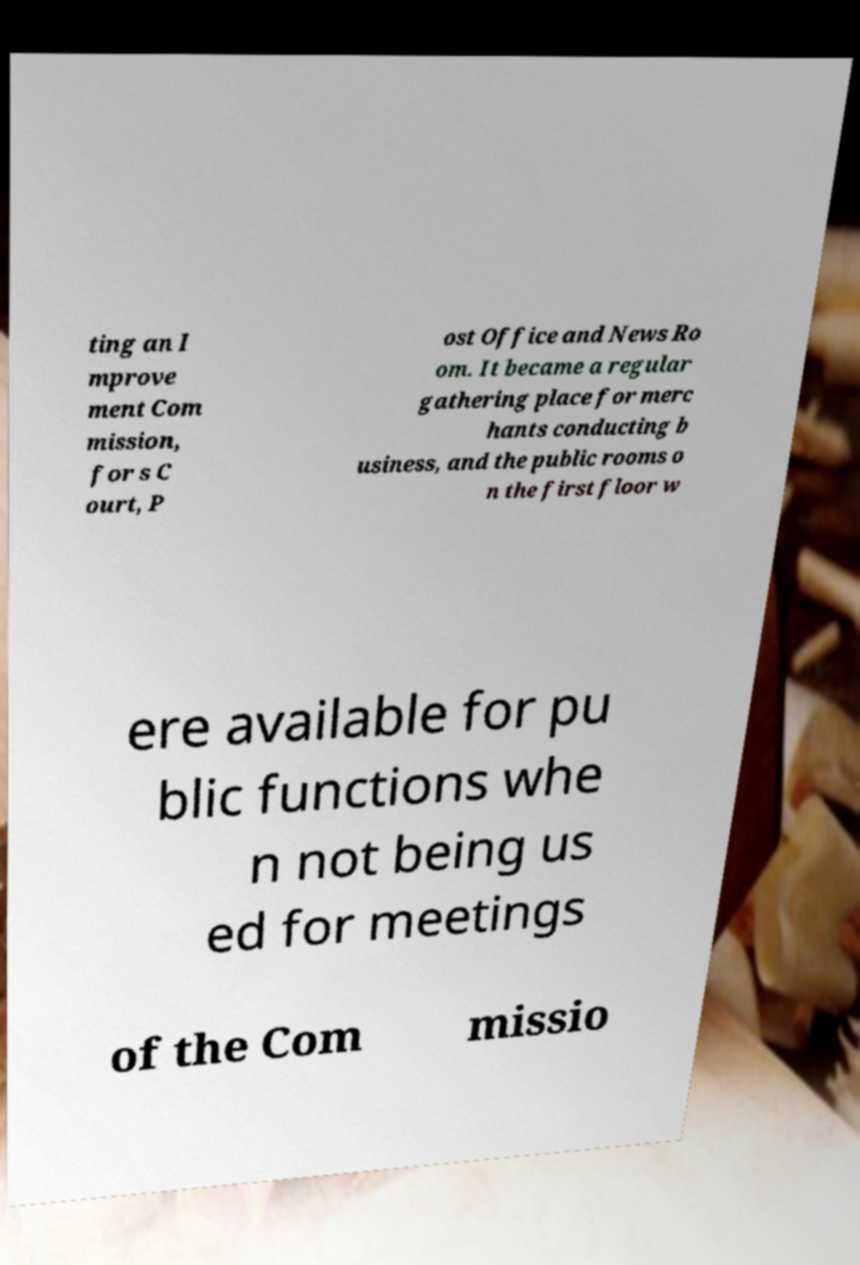For documentation purposes, I need the text within this image transcribed. Could you provide that? ting an I mprove ment Com mission, for s C ourt, P ost Office and News Ro om. It became a regular gathering place for merc hants conducting b usiness, and the public rooms o n the first floor w ere available for pu blic functions whe n not being us ed for meetings of the Com missio 